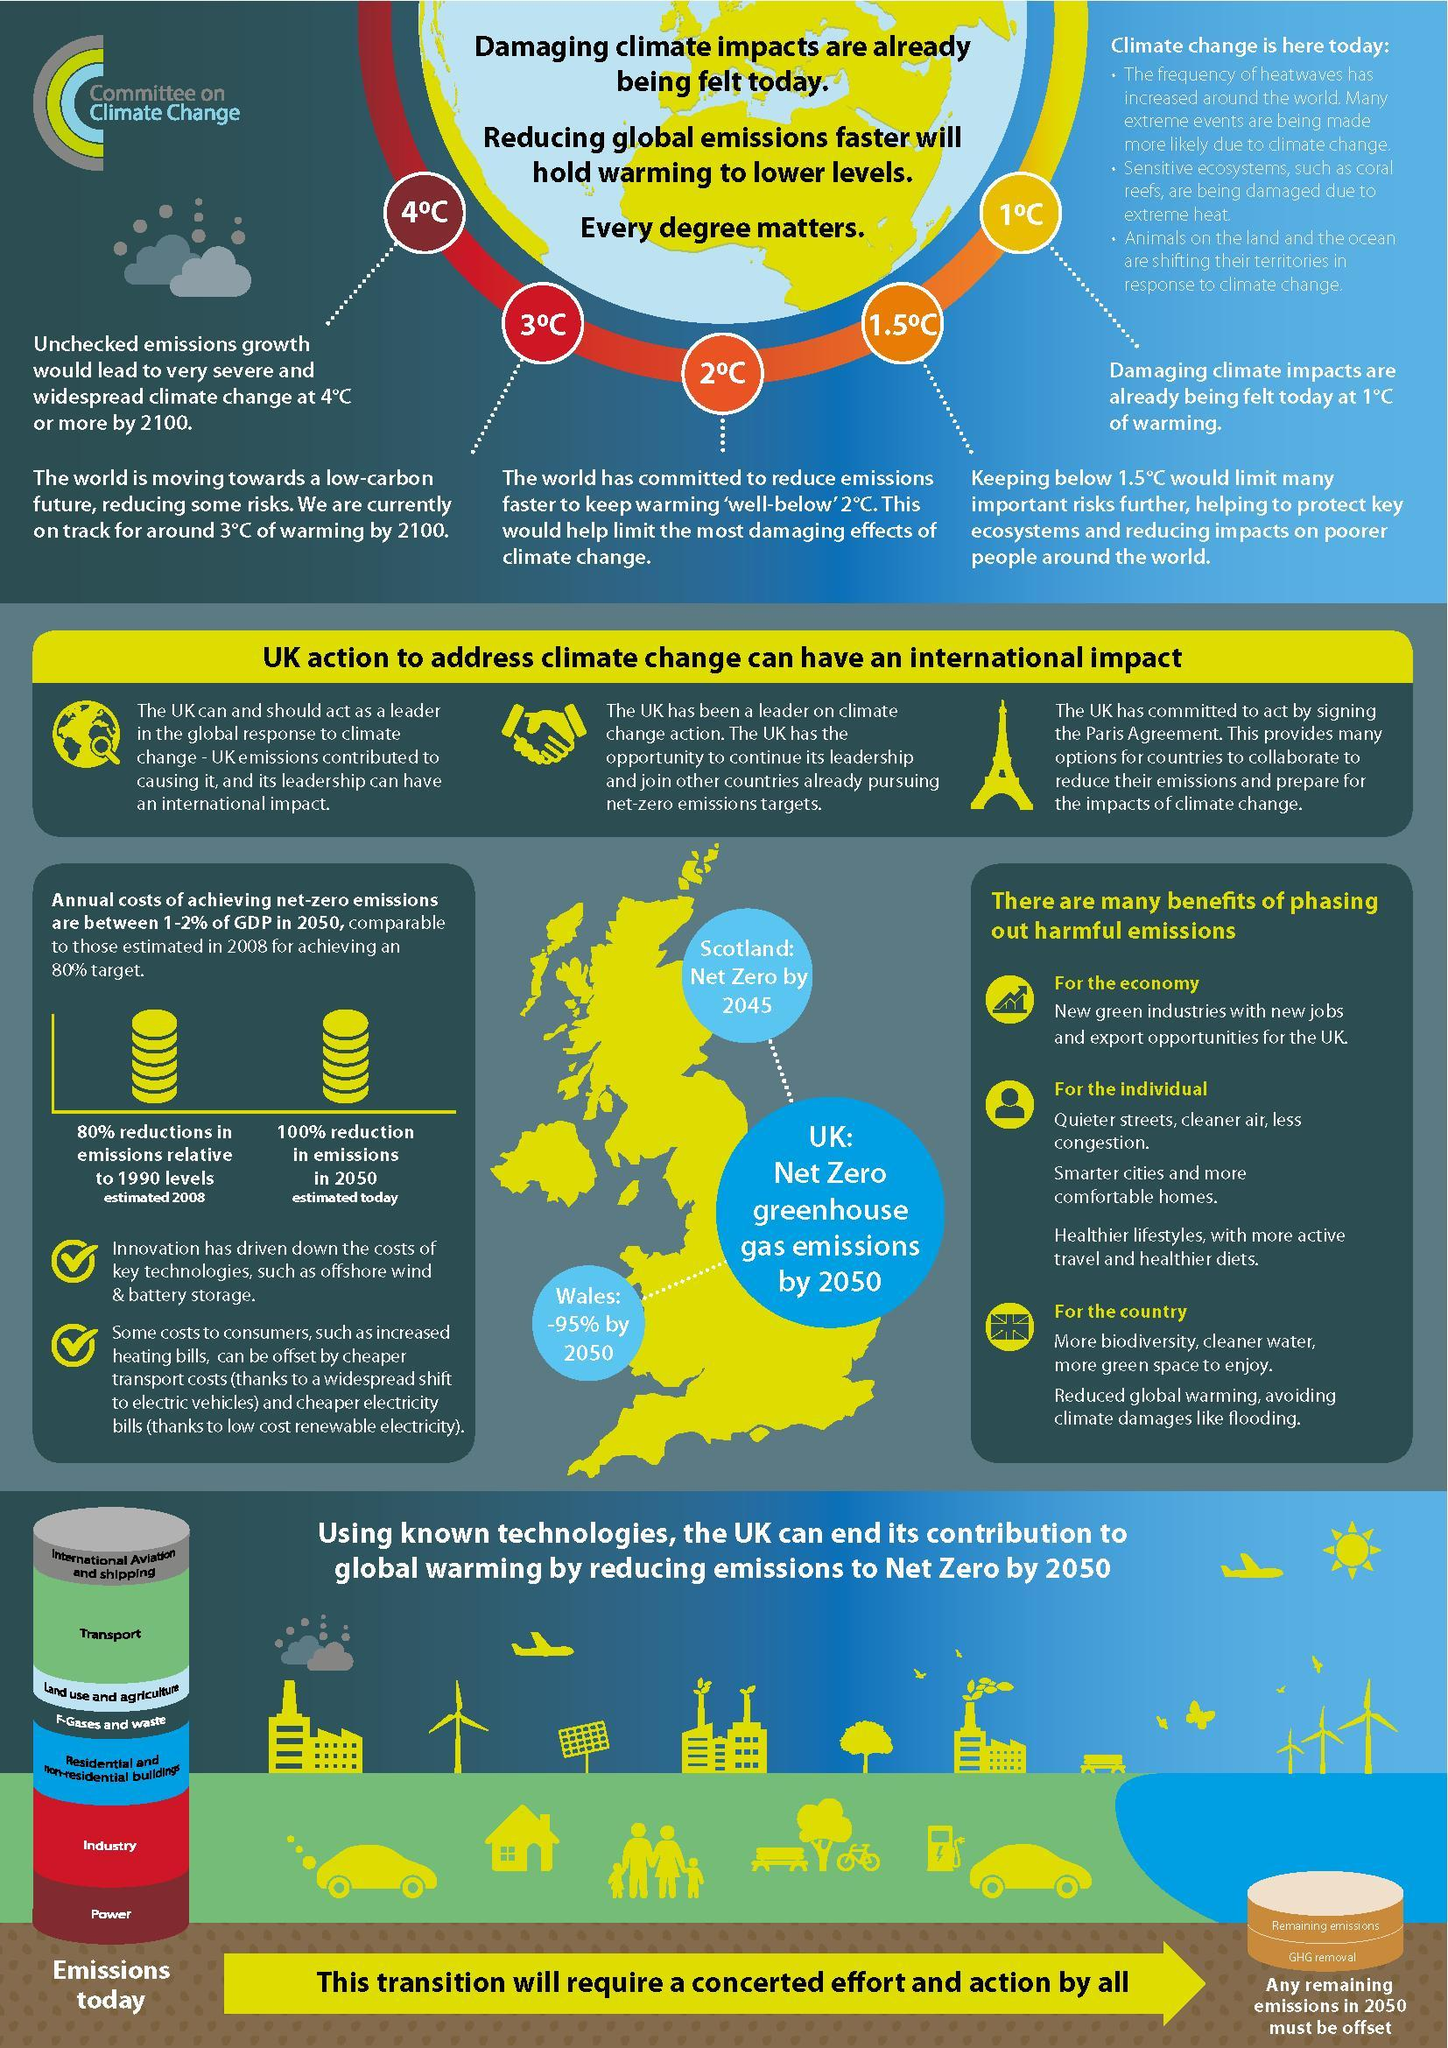What is the predicted growth in climate change by 2100 in degree Celsius, if no precautions are taken?
Answer the question with a short phrase. 4 Which regions in the UK would cut down greenhouse emissions to more than 90% by 2050? Scotland, UK, Wales What would be the difference in temperature in degree Celsius if green houses gases were kept in check until 2100? 1 